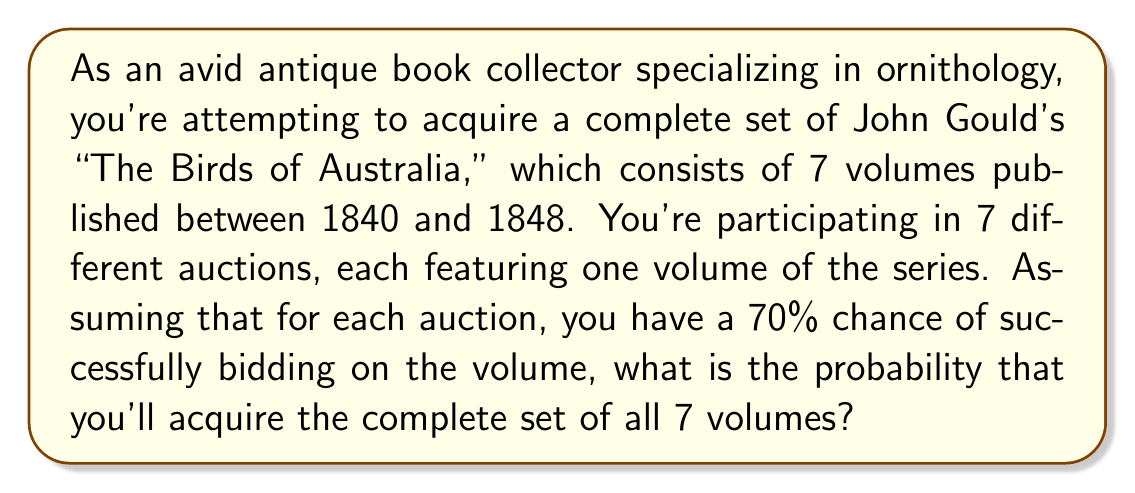Can you answer this question? To solve this problem, we need to consider the following:

1. Each auction is an independent event.
2. We need to succeed in all 7 auctions to complete the set.
3. The probability of success for each auction is 70% or 0.7.

This scenario follows the multiplication rule of probability for independent events. To find the probability of all events occurring together, we multiply the individual probabilities:

$$P(\text{complete set}) = P(\text{vol 1}) \times P(\text{vol 2}) \times P(\text{vol 3}) \times P(\text{vol 4}) \times P(\text{vol 5}) \times P(\text{vol 6}) \times P(\text{vol 7})$$

Since each probability is 0.7, we can simplify this to:

$$P(\text{complete set}) = 0.7^7$$

Now, let's calculate:

$$\begin{align}
P(\text{complete set}) &= 0.7^7 \\
&= 0.7 \times 0.7 \times 0.7 \times 0.7 \times 0.7 \times 0.7 \times 0.7 \\
&\approx 0.0823543
\end{align}$$

To express this as a percentage:

$$0.0823543 \times 100\% \approx 8.24\%$$
Answer: The probability of acquiring the complete set of all 7 volumes is approximately 0.0824 or 8.24%. 